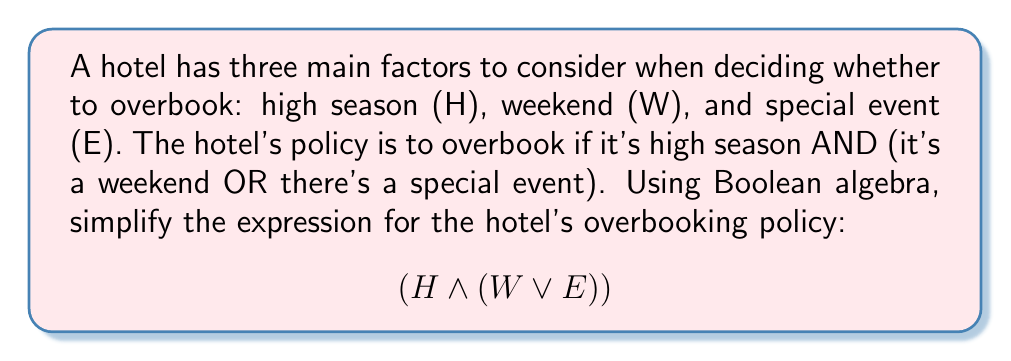Provide a solution to this math problem. To simplify this Boolean expression, we'll follow these steps:

1. First, we note that the expression is already in its simplest form according to the given policy. However, we can demonstrate why this is the case:

2. Let's apply the distributive law to expand the expression:
   $$(H \land (W \lor E)) = (H \land W) \lor (H \land E)$$

3. This expanded form shows that the hotel will overbook in two scenarios:
   a) When it's high season AND a weekend $(H \land W)$
   b) When it's high season AND there's a special event $(H \land E)$

4. We can't simplify this further because:
   - We can't factor out $H$ as it's required in both scenarios
   - $W$ and $E$ are independent variables and can't be combined

5. Therefore, the original expression $$(H \land (W \lor E))$$ is already in its simplest form and accurately represents the hotel's overbooking policy.

6. In practical terms, this means the hotel owner should overbook when:
   - It's high season AND (it's a weekend OR there's a special event)

This Boolean expression efficiently streamlines the decision-making process for the hotel's overbooking policy.
Answer: $$(H \land (W \lor E))$$ 